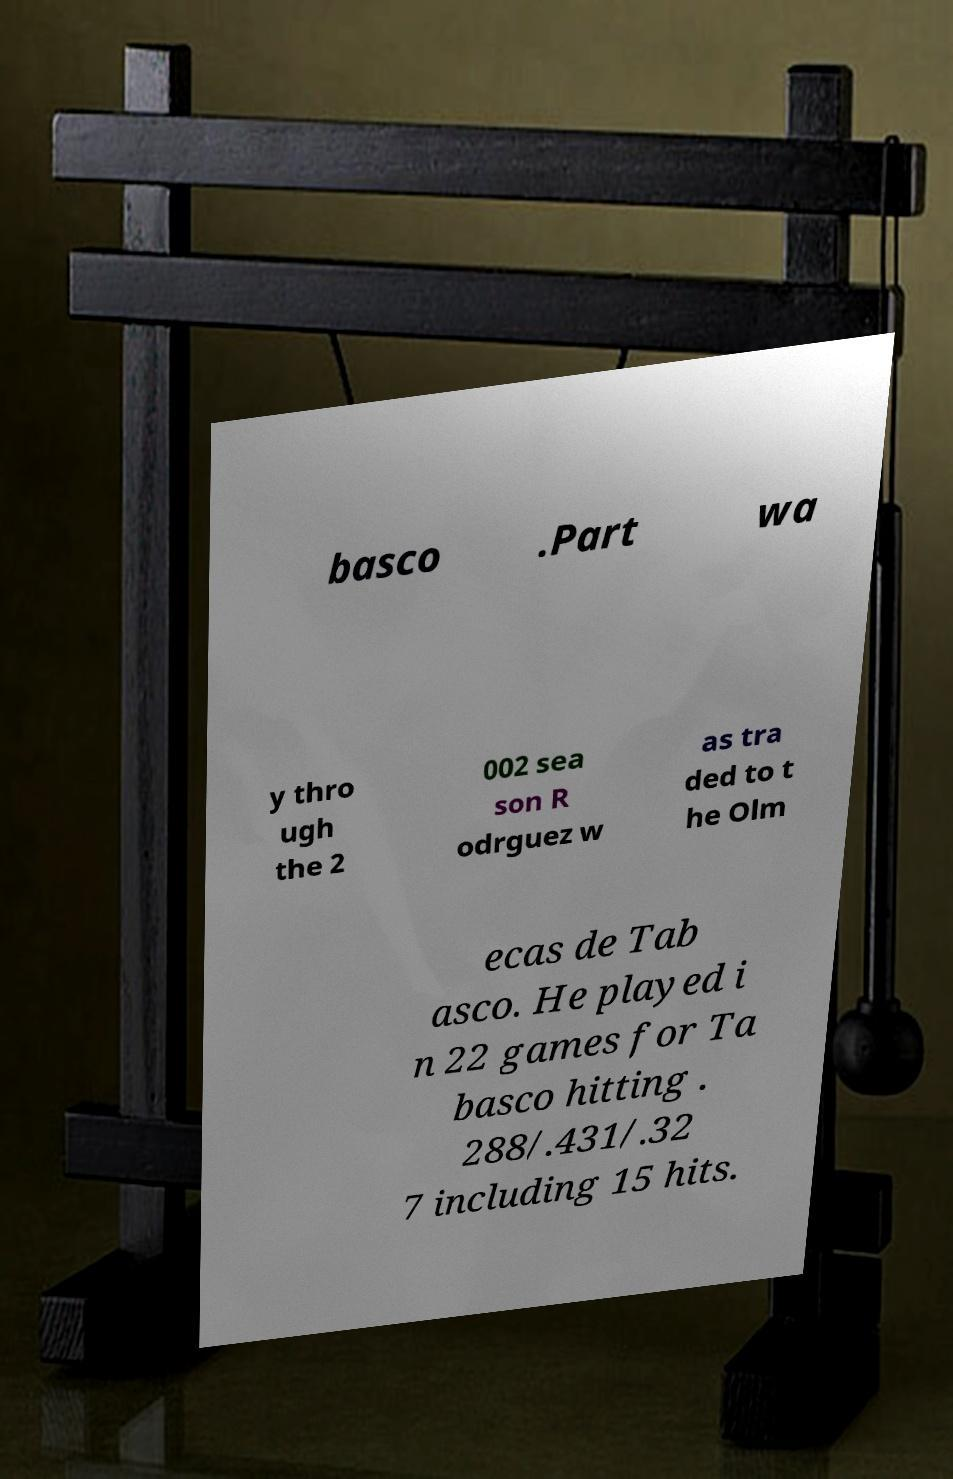Can you accurately transcribe the text from the provided image for me? basco .Part wa y thro ugh the 2 002 sea son R odrguez w as tra ded to t he Olm ecas de Tab asco. He played i n 22 games for Ta basco hitting . 288/.431/.32 7 including 15 hits. 